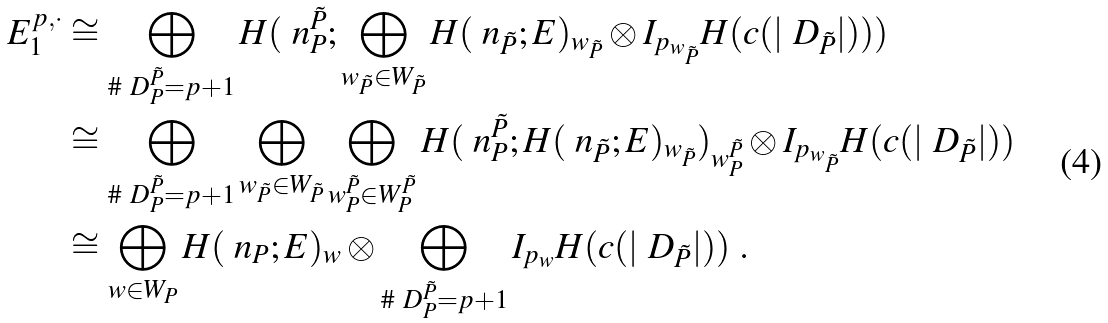Convert formula to latex. <formula><loc_0><loc_0><loc_500><loc_500>E _ { 1 } ^ { p , \cdot } & \cong \bigoplus _ { \# \ D _ { P } ^ { \tilde { P } } = p + 1 } H ( \ n _ { P } ^ { \tilde { P } } ; \bigoplus _ { w _ { \tilde { P } } \in W _ { \tilde { P } } } H ( \ n _ { \tilde { P } } ; E ) _ { w _ { \tilde { P } } } \otimes I _ { p _ { w _ { \tilde { P } } } } H ( c ( | \ D _ { \tilde { P } } | ) ) ) \\ & \cong \bigoplus _ { \# \ D _ { P } ^ { \tilde { P } } = p + 1 } \bigoplus _ { w _ { \tilde { P } } \in W _ { \tilde { P } } } \bigoplus _ { w ^ { \tilde { P } } _ { P } \in W ^ { \tilde { P } } _ { P } } H ( \ n _ { P } ^ { \tilde { P } } ; H ( \ n _ { \tilde { P } } ; E ) _ { w _ { \tilde { P } } } ) _ { w ^ { \tilde { P } } _ { P } } \otimes I _ { p _ { w _ { \tilde { P } } } } H ( c ( | \ D _ { \tilde { P } } | ) ) \\ & \cong \bigoplus _ { w \in W _ { P } } H ( \ n _ { P } ; E ) _ { w } \otimes \bigoplus _ { \# \ D _ { P } ^ { \tilde { P } } = p + 1 } I _ { p _ { w } } H ( c ( | \ D _ { \tilde { P } } | ) ) \ .</formula> 